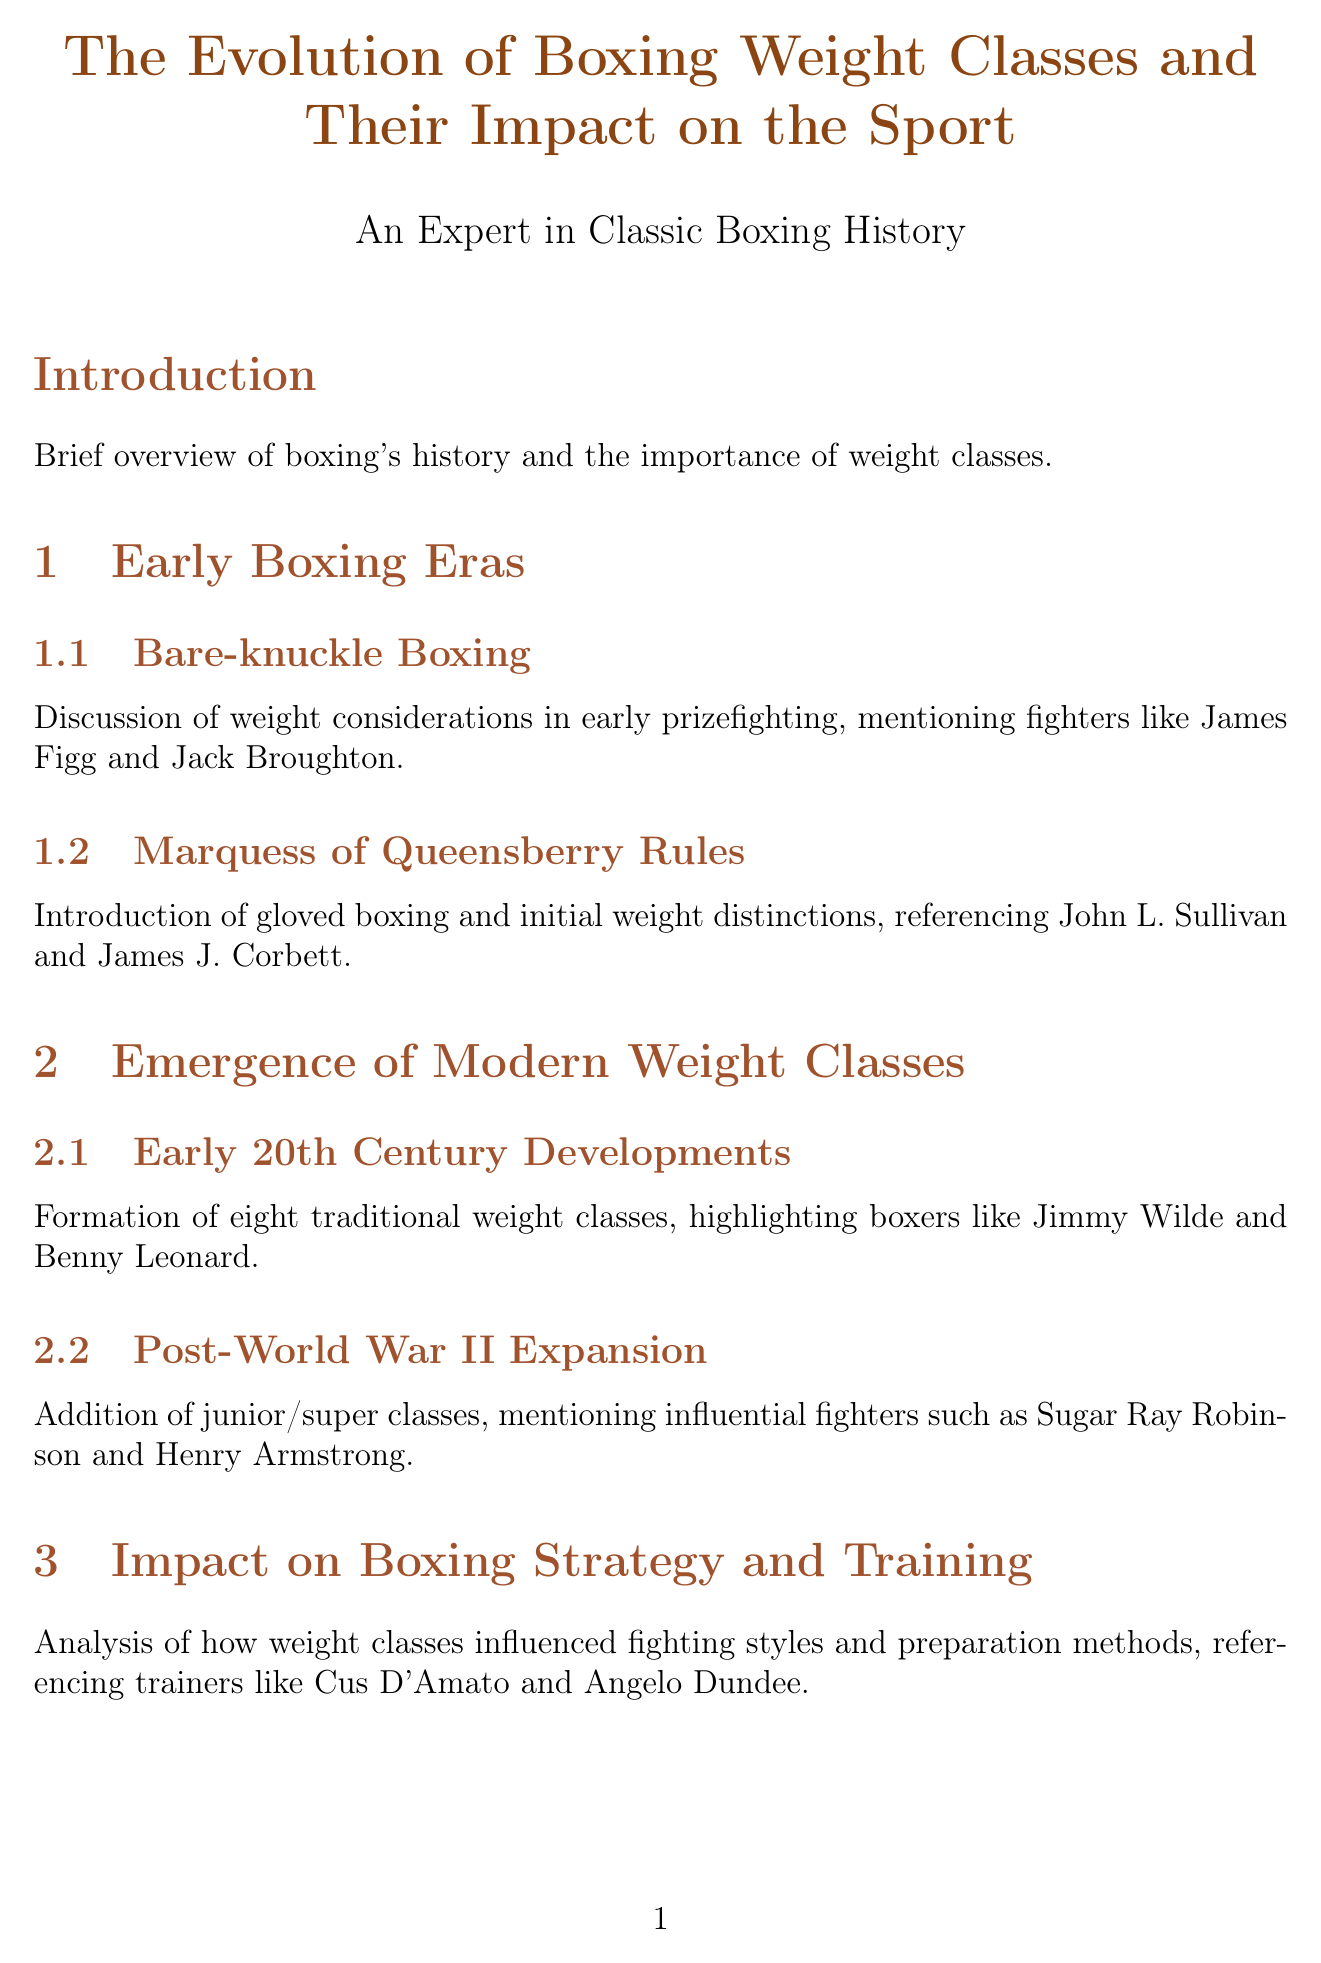What is the title of the document? The title is explicitly stated at the start of the document.
Answer: The Evolution of Boxing Weight Classes and Their Impact on the Sport How many current professional male weight divisions are there? The document provides statistics about current professional male divisions.
Answer: 17 Who introduced the Marquess of Queensberry Rules? The document lists key figures related to early boxing rules.
Answer: John L. Sullivan What year was the National Sporting Club of London established for weight divisions? The document gives a specific year related to boxing history.
Answer: 1909 Which boxer is highlighted in the discussion about catchweight bouts? The document includes specific fights associated with boxers.
Answer: Oscar De La Hoya How many Olympic female boxing divisions currently exist? The document provides statistics about Olympic weight divisions.
Answer: 5 What is one of the cultural impacts mentioned in the document? The document lists various cultural impacts of boxing weight classes.
Answer: Influence on popular culture and literature What is the significance of the weight classes in boxing according to the report? The conclusion summarizes the broader impact of weight classes in boxing.
Answer: Cultural and sporting significance Who are two notable multi-division champions mentioned? The document profiles boxers who succeeded across weight classes.
Answer: Manny Pacquiao and Floyd Mayweather Jr 